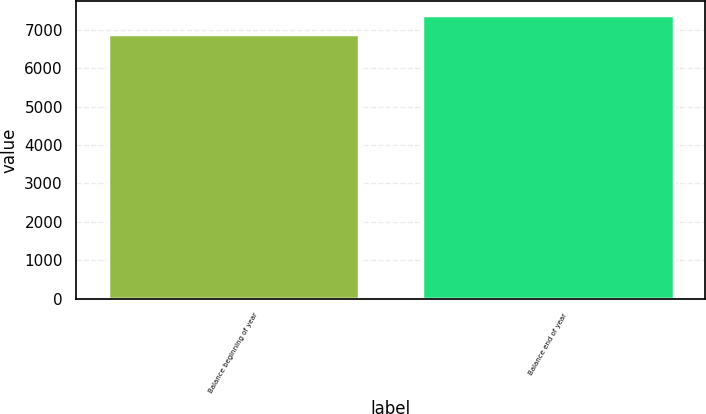Convert chart. <chart><loc_0><loc_0><loc_500><loc_500><bar_chart><fcel>Balance beginning of year<fcel>Balance end of year<nl><fcel>6878<fcel>7370<nl></chart> 